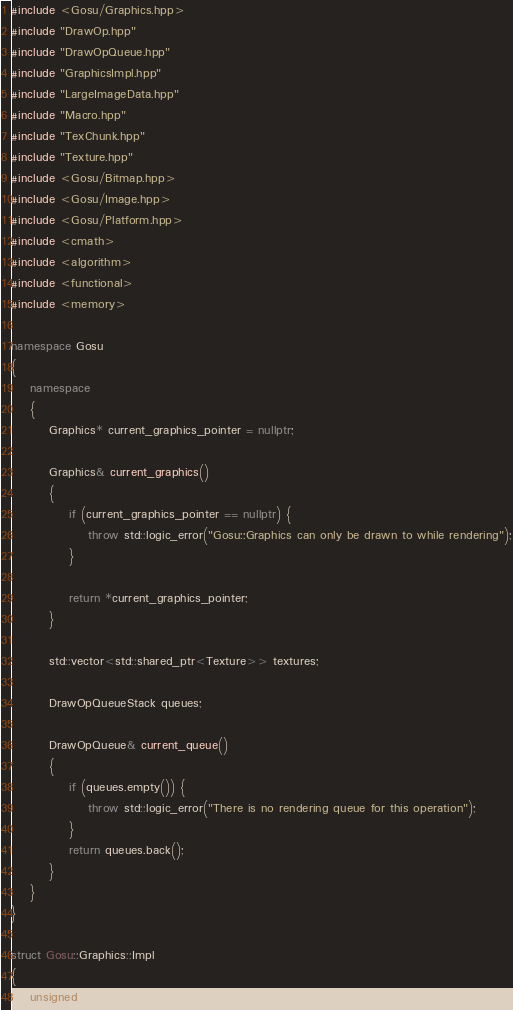Convert code to text. <code><loc_0><loc_0><loc_500><loc_500><_C++_>#include <Gosu/Graphics.hpp>
#include "DrawOp.hpp"
#include "DrawOpQueue.hpp"
#include "GraphicsImpl.hpp"
#include "LargeImageData.hpp"
#include "Macro.hpp"
#include "TexChunk.hpp"
#include "Texture.hpp"
#include <Gosu/Bitmap.hpp>
#include <Gosu/Image.hpp>
#include <Gosu/Platform.hpp>
#include <cmath>
#include <algorithm>
#include <functional>
#include <memory>

namespace Gosu
{
    namespace
    {
        Graphics* current_graphics_pointer = nullptr;
        
        Graphics& current_graphics()
        {
            if (current_graphics_pointer == nullptr) {
                throw std::logic_error("Gosu::Graphics can only be drawn to while rendering");
            }
            
            return *current_graphics_pointer;
        }
        
        std::vector<std::shared_ptr<Texture>> textures;
        
        DrawOpQueueStack queues;
        
        DrawOpQueue& current_queue()
        {
            if (queues.empty()) {
                throw std::logic_error("There is no rendering queue for this operation");
            }
            return queues.back();
        }
    }
}

struct Gosu::Graphics::Impl
{
    unsigned virt_width, virt_height;</code> 